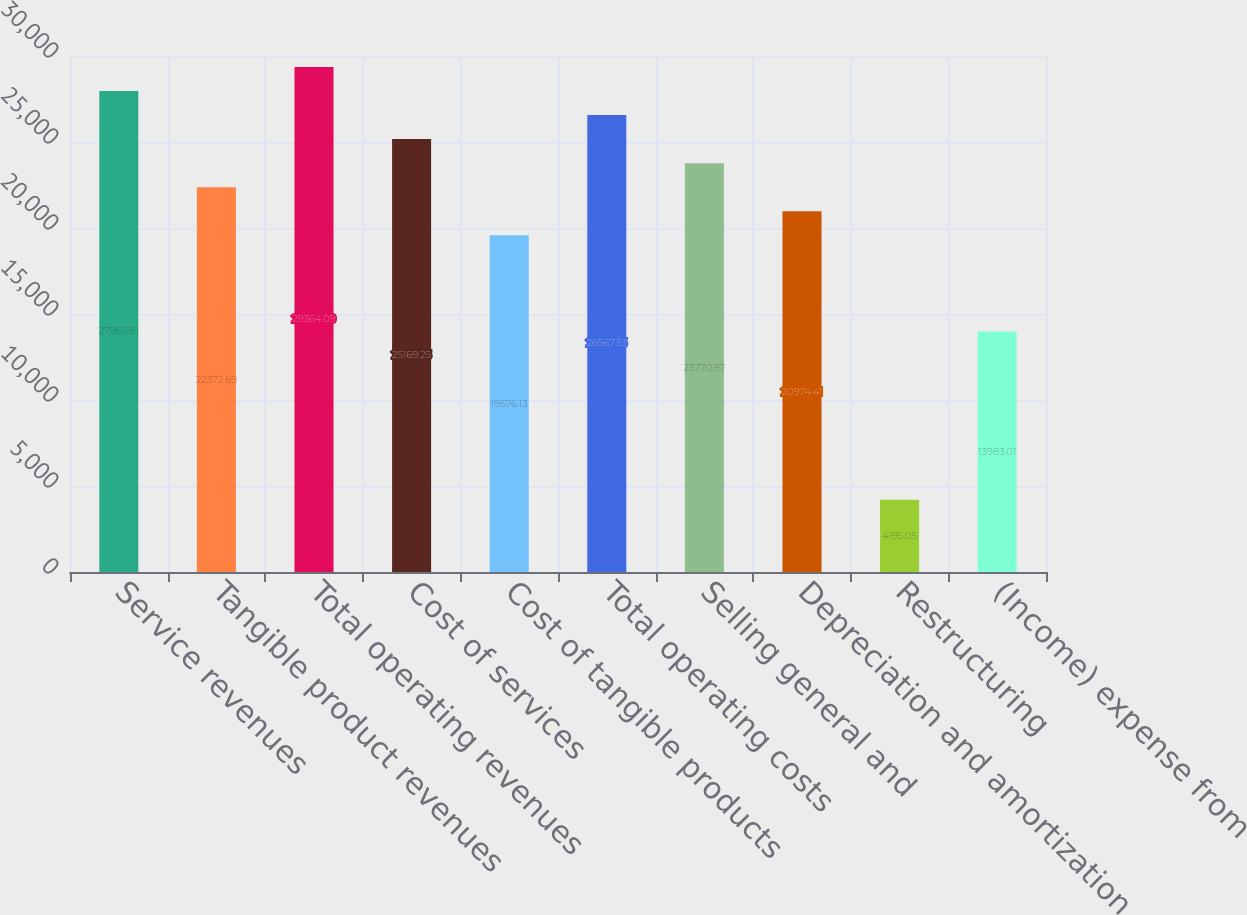<chart> <loc_0><loc_0><loc_500><loc_500><bar_chart><fcel>Service revenues<fcel>Tangible product revenues<fcel>Total operating revenues<fcel>Cost of services<fcel>Cost of tangible products<fcel>Total operating costs<fcel>Selling general and<fcel>Depreciation and amortization<fcel>Restructuring<fcel>(Income) expense from<nl><fcel>27965.8<fcel>22372.7<fcel>29364.1<fcel>25169.2<fcel>19576.1<fcel>26567.5<fcel>23771<fcel>20974.4<fcel>4195.05<fcel>13983<nl></chart> 